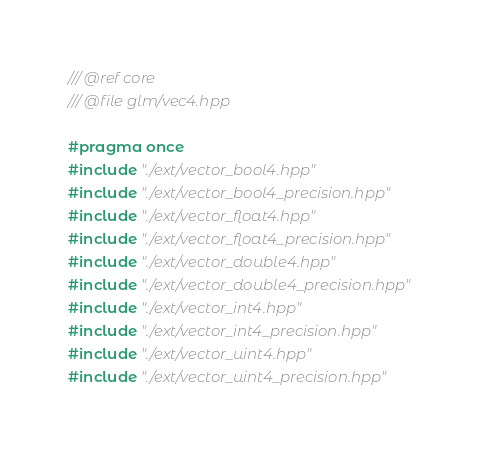<code> <loc_0><loc_0><loc_500><loc_500><_C++_>/// @ref core
/// @file glm/vec4.hpp

#pragma once
#include "./ext/vector_bool4.hpp"
#include "./ext/vector_bool4_precision.hpp"
#include "./ext/vector_float4.hpp"
#include "./ext/vector_float4_precision.hpp"
#include "./ext/vector_double4.hpp"
#include "./ext/vector_double4_precision.hpp"
#include "./ext/vector_int4.hpp"
#include "./ext/vector_int4_precision.hpp"
#include "./ext/vector_uint4.hpp"
#include "./ext/vector_uint4_precision.hpp"</code> 